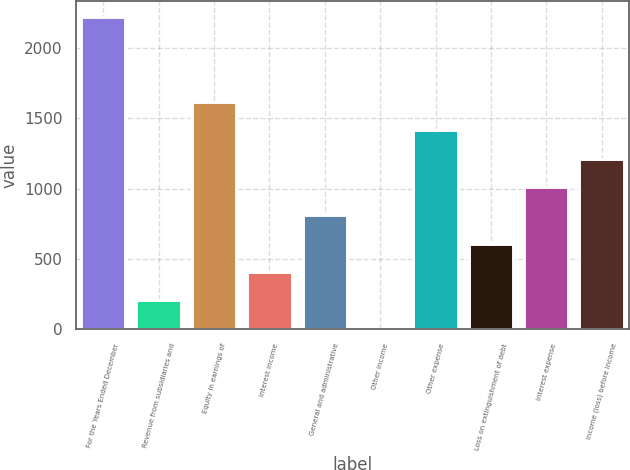Convert chart to OTSL. <chart><loc_0><loc_0><loc_500><loc_500><bar_chart><fcel>For the Years Ended December<fcel>Revenue from subsidiaries and<fcel>Equity in earnings of<fcel>Interest income<fcel>General and administrative<fcel>Other income<fcel>Other expense<fcel>Loss on extinguishment of debt<fcel>Interest expense<fcel>Income (loss) before income<nl><fcel>2218.2<fcel>206.2<fcel>1614.6<fcel>407.4<fcel>809.8<fcel>5<fcel>1413.4<fcel>608.6<fcel>1011<fcel>1212.2<nl></chart> 